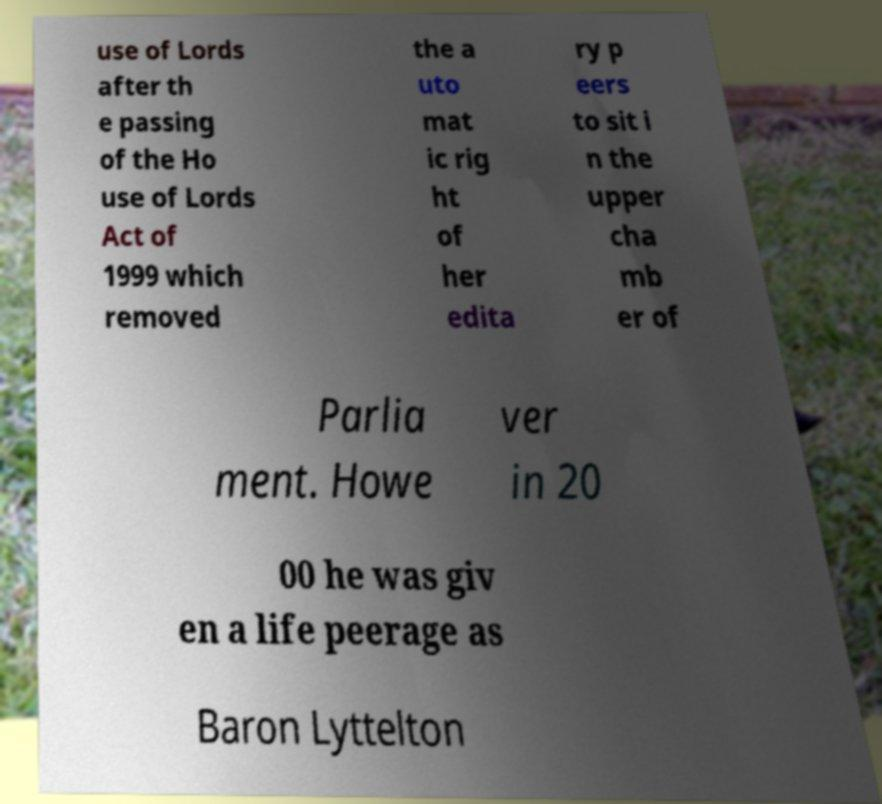For documentation purposes, I need the text within this image transcribed. Could you provide that? use of Lords after th e passing of the Ho use of Lords Act of 1999 which removed the a uto mat ic rig ht of her edita ry p eers to sit i n the upper cha mb er of Parlia ment. Howe ver in 20 00 he was giv en a life peerage as Baron Lyttelton 